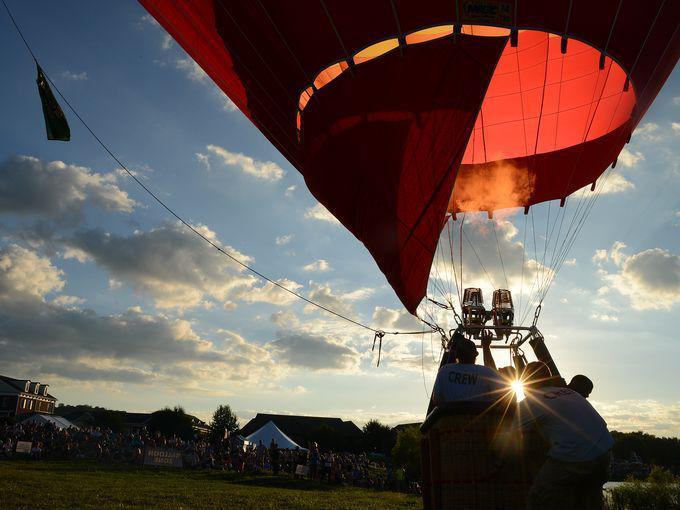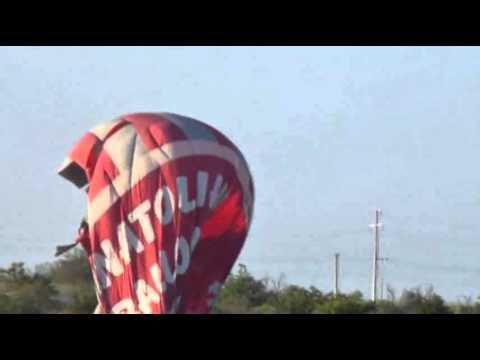The first image is the image on the left, the second image is the image on the right. For the images displayed, is the sentence "In the left image, there is a single balloon that is red, white and blue." factually correct? Answer yes or no. No. The first image is the image on the left, the second image is the image on the right. Evaluate the accuracy of this statement regarding the images: "One image shows a red, white and blue balloon with stripes, and the other shows a multicolored striped balloon with at least six colors.". Is it true? Answer yes or no. No. 